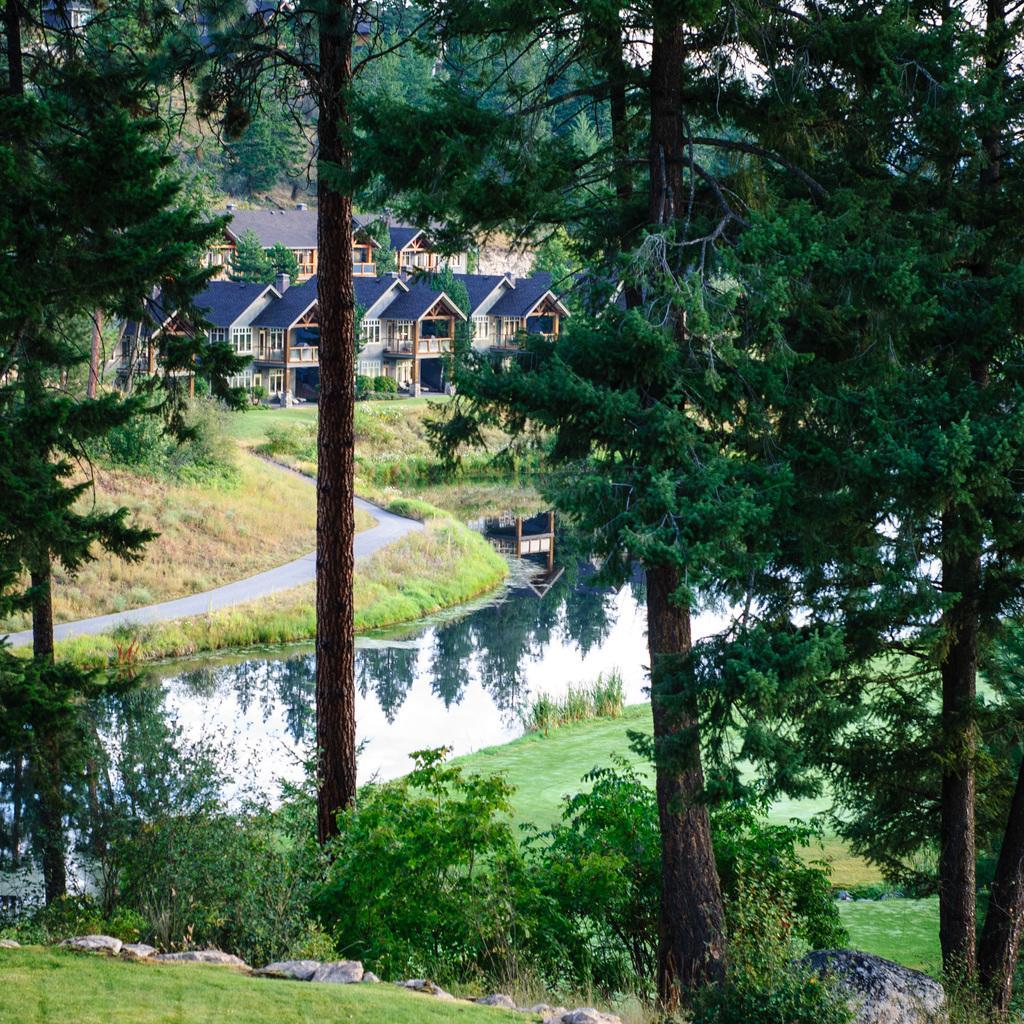In one or two sentences, can you explain what this image depicts? In the image there are few trees around a grass surface and there is a lake, behind the lake there are many houses. 